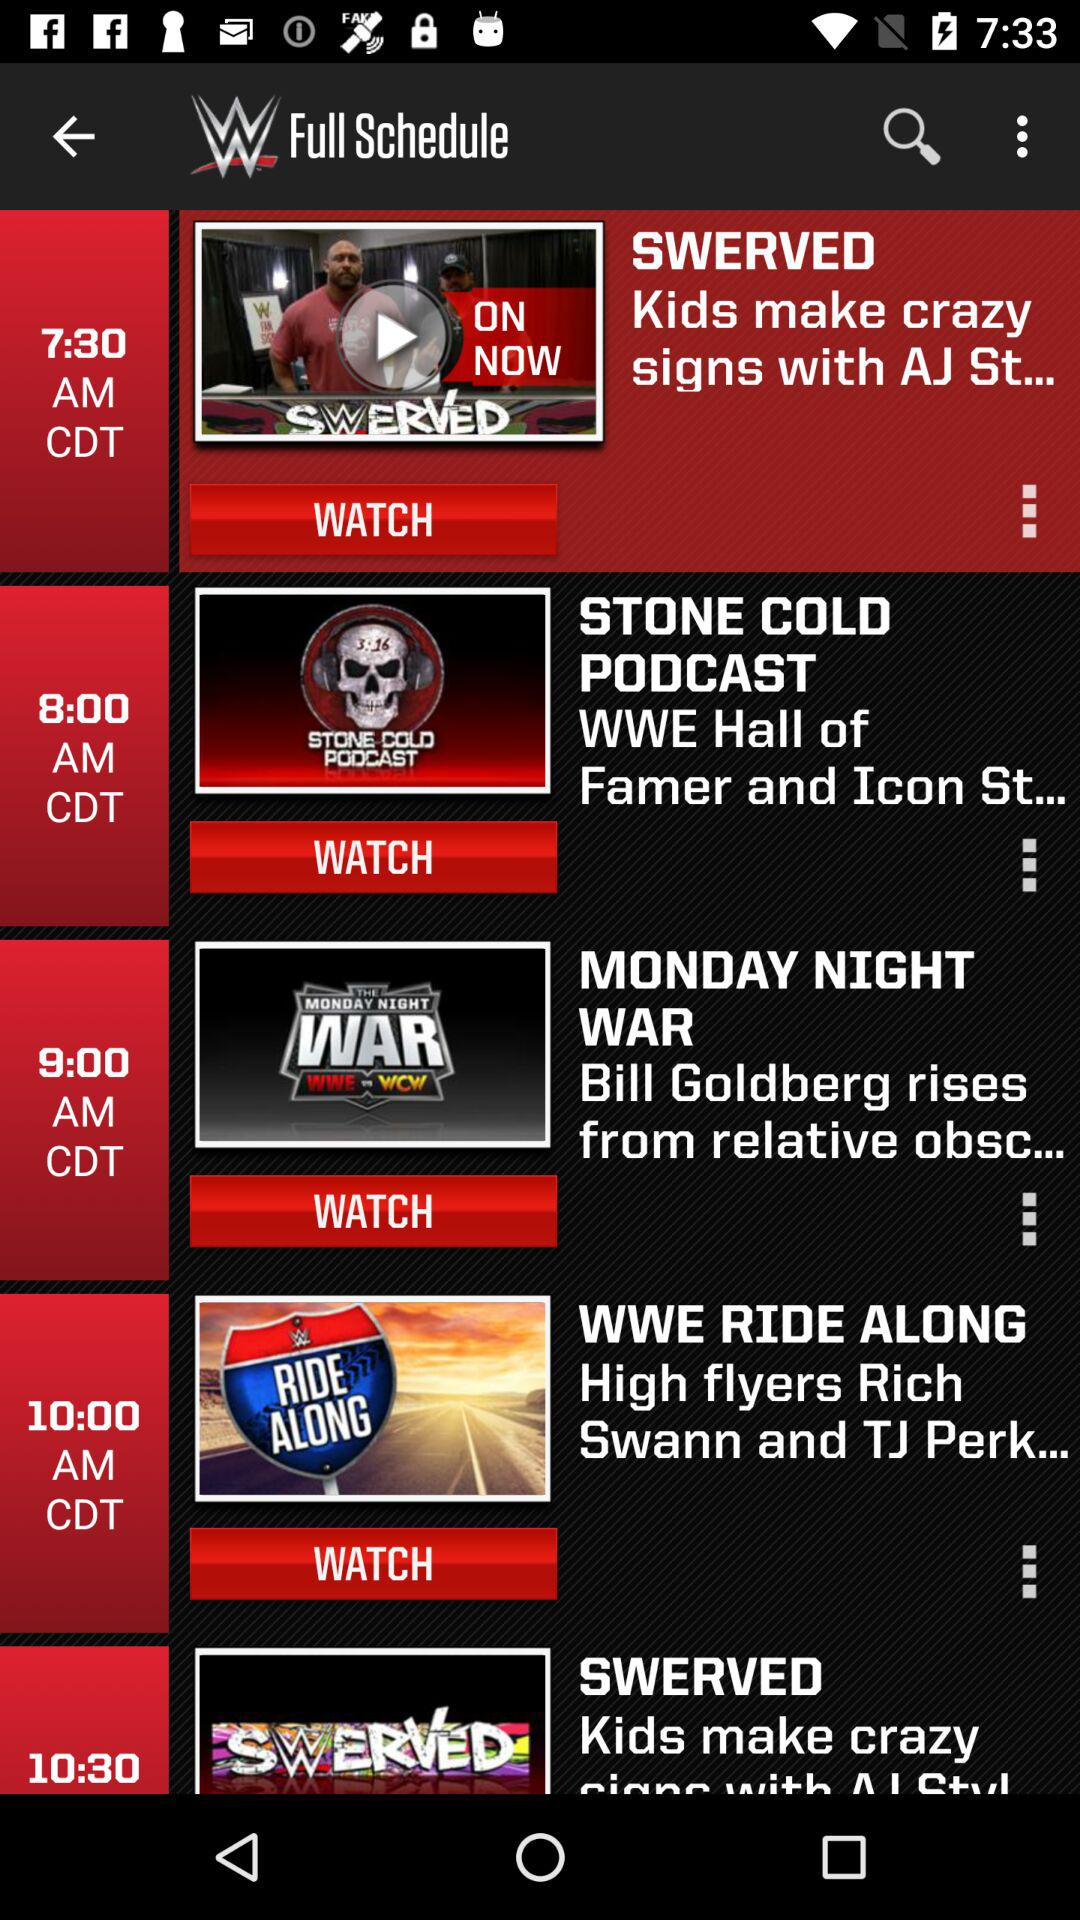At what time is "WWE RIDE ALONG" scheduled to air? "WWE RIDE ALONG" is scheduled to air at 10:00 a.m. CDT. 